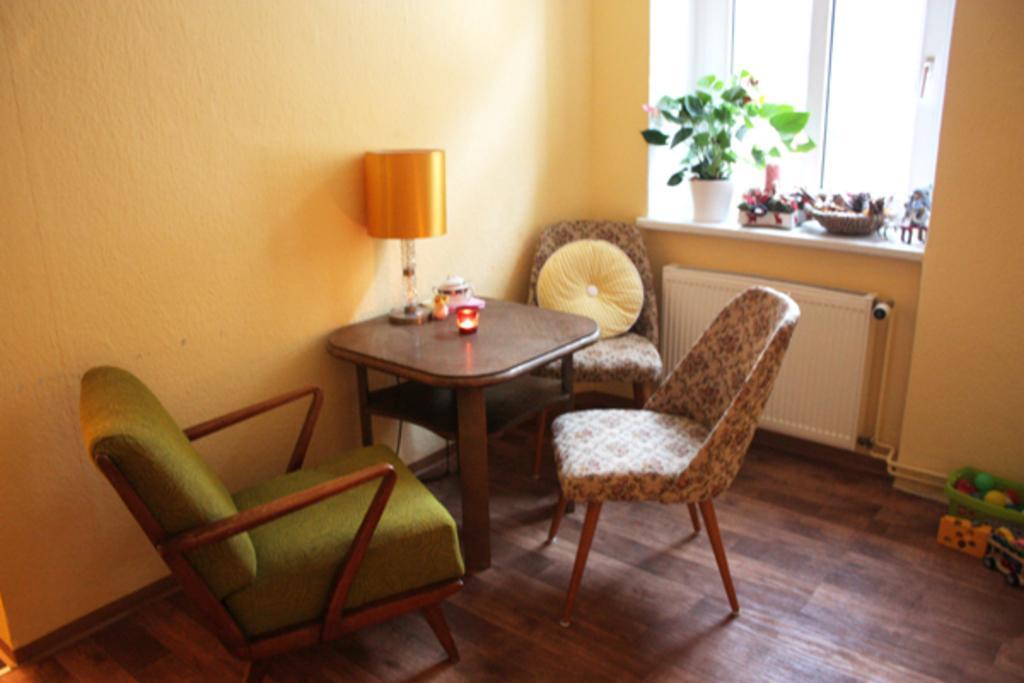Can you describe this image briefly? In this picture we can see a room with chairs, table, pillows and on table we have lamp, candles and in background we can see wall, window, flower pot with plant in it, basket at window and on floor we can see some toys. 